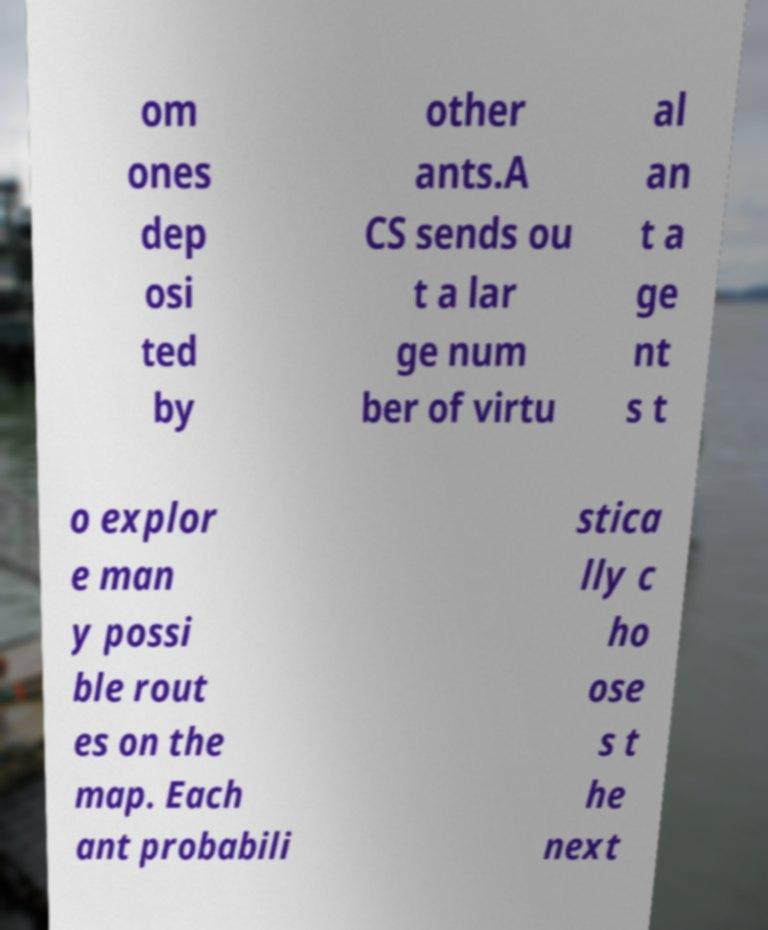There's text embedded in this image that I need extracted. Can you transcribe it verbatim? om ones dep osi ted by other ants.A CS sends ou t a lar ge num ber of virtu al an t a ge nt s t o explor e man y possi ble rout es on the map. Each ant probabili stica lly c ho ose s t he next 